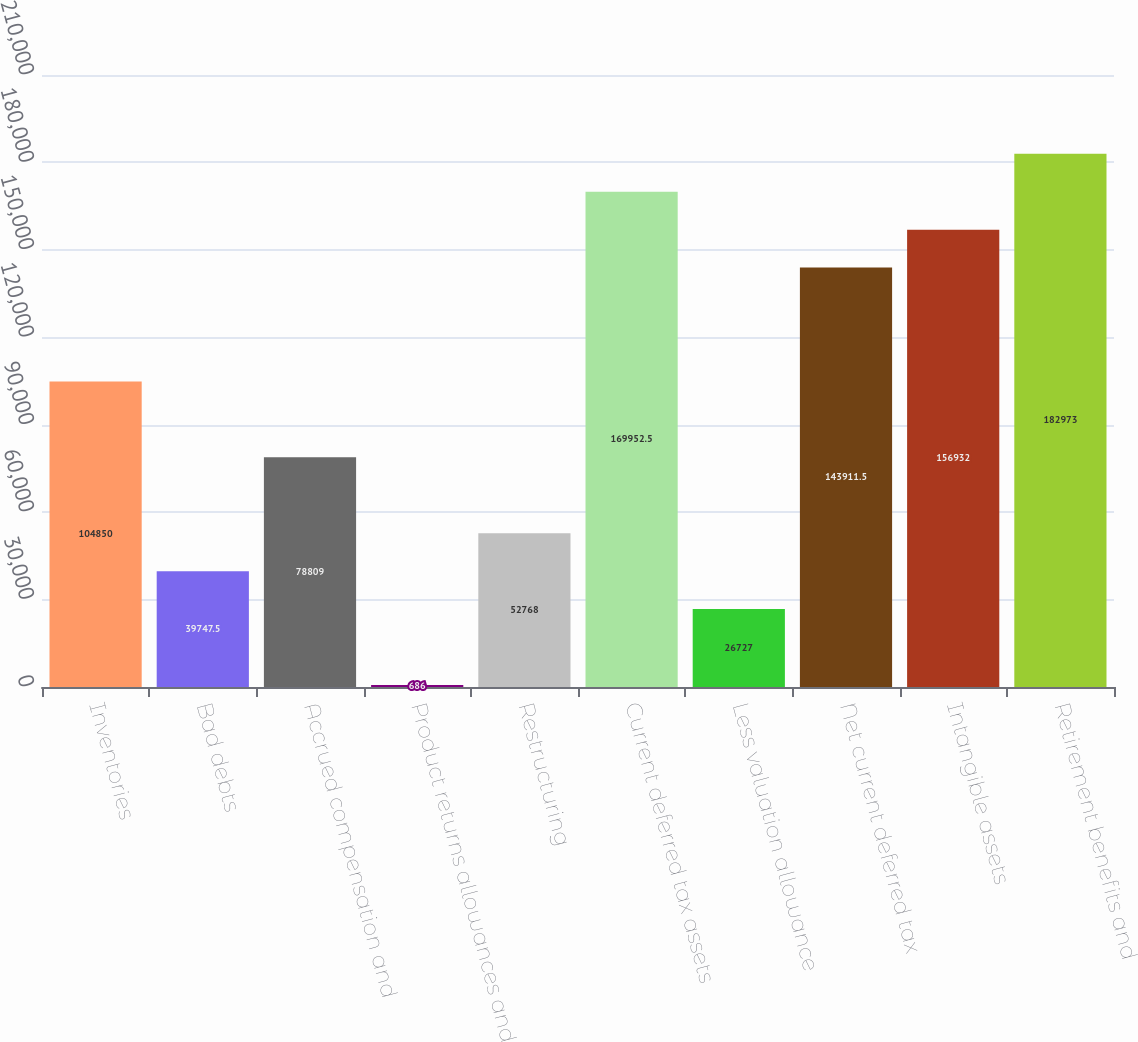Convert chart. <chart><loc_0><loc_0><loc_500><loc_500><bar_chart><fcel>Inventories<fcel>Bad debts<fcel>Accrued compensation and<fcel>Product returns allowances and<fcel>Restructuring<fcel>Current deferred tax assets<fcel>Less valuation allowance<fcel>Net current deferred tax<fcel>Intangible assets<fcel>Retirement benefits and<nl><fcel>104850<fcel>39747.5<fcel>78809<fcel>686<fcel>52768<fcel>169952<fcel>26727<fcel>143912<fcel>156932<fcel>182973<nl></chart> 